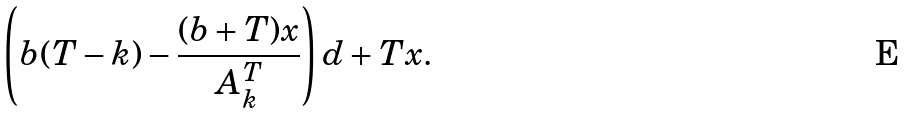Convert formula to latex. <formula><loc_0><loc_0><loc_500><loc_500>\left ( b ( T - k ) - \frac { ( b + T ) x } { A ^ { T } _ { k } } \right ) d + T x .</formula> 